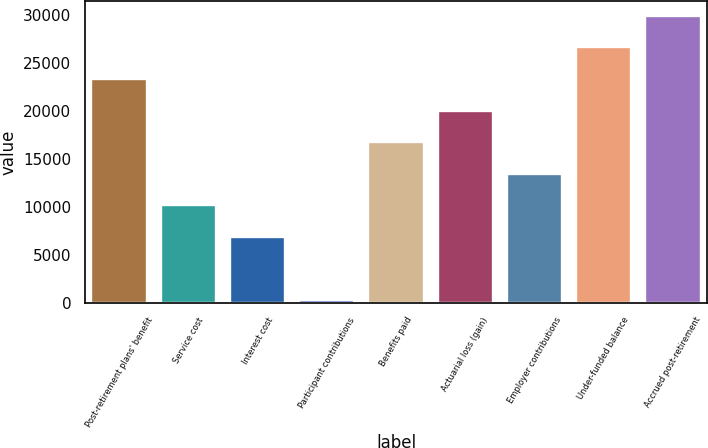Convert chart to OTSL. <chart><loc_0><loc_0><loc_500><loc_500><bar_chart><fcel>Post-retirement plans' benefit<fcel>Service cost<fcel>Interest cost<fcel>Participant contributions<fcel>Benefits paid<fcel>Actuarial loss (gain)<fcel>Employer contributions<fcel>Under-funded balance<fcel>Accrued post-retirement<nl><fcel>23316.7<fcel>10132.3<fcel>6836.2<fcel>244<fcel>16724.5<fcel>20020.6<fcel>13428.4<fcel>26612.8<fcel>29908.9<nl></chart> 